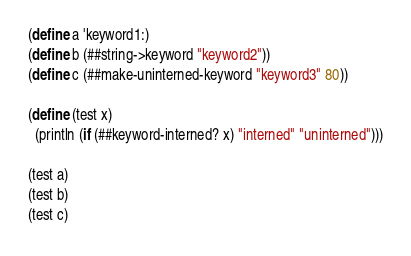<code> <loc_0><loc_0><loc_500><loc_500><_Scheme_>(define a 'keyword1:)
(define b (##string->keyword "keyword2"))
(define c (##make-uninterned-keyword "keyword3" 80))

(define (test x)
  (println (if (##keyword-interned? x) "interned" "uninterned")))

(test a)
(test b)
(test c)
</code> 